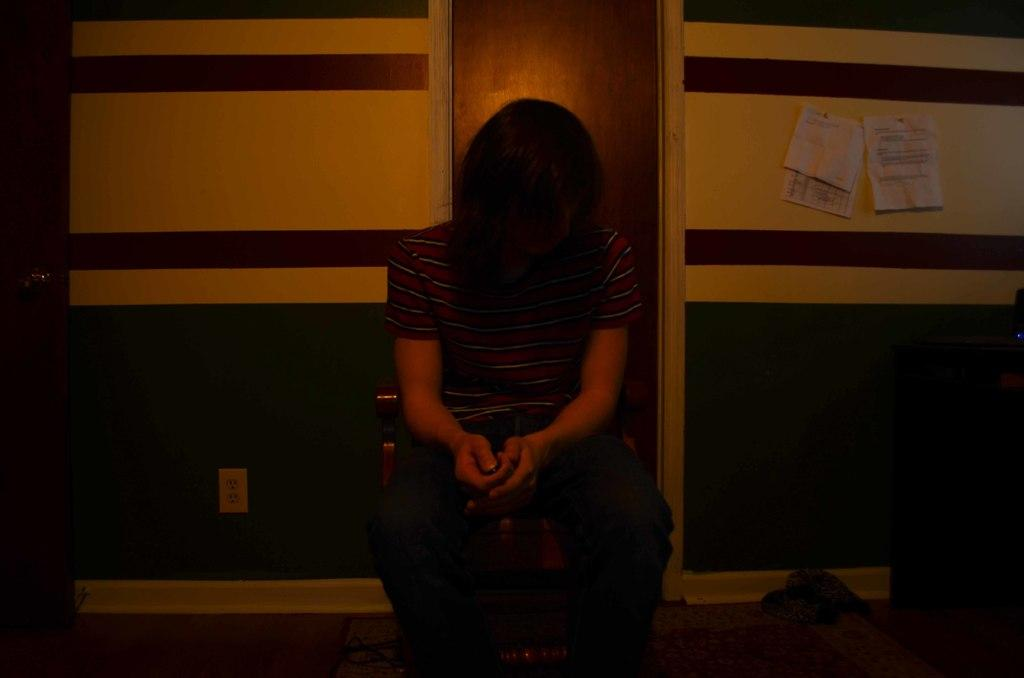What is the person in the image doing? The person is sitting on a chair in the image. What can be seen in the background of the image? There is a wooden door and a wall in the background of the image. Are there any objects or items attached to the wall? Yes, there are papers attached to the wall on the right side. What type of error can be seen on the dolls in the image? There are no dolls present in the image, so it is not possible to determine if there are any errors on them. 